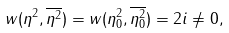Convert formula to latex. <formula><loc_0><loc_0><loc_500><loc_500>w ( \eta ^ { 2 } , \overline { \eta ^ { 2 } } ) = w ( \eta ^ { 2 } _ { 0 } , \overline { \eta ^ { 2 } _ { 0 } } ) = 2 i \neq 0 ,</formula> 